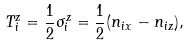Convert formula to latex. <formula><loc_0><loc_0><loc_500><loc_500>T _ { i } ^ { z } = \frac { 1 } { 2 } \sigma _ { i } ^ { z } = \frac { 1 } { 2 } ( n _ { i x } - n _ { i z } ) ,</formula> 